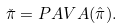<formula> <loc_0><loc_0><loc_500><loc_500>\check { \pi } = P A V A ( \hat { \pi } ) .</formula> 